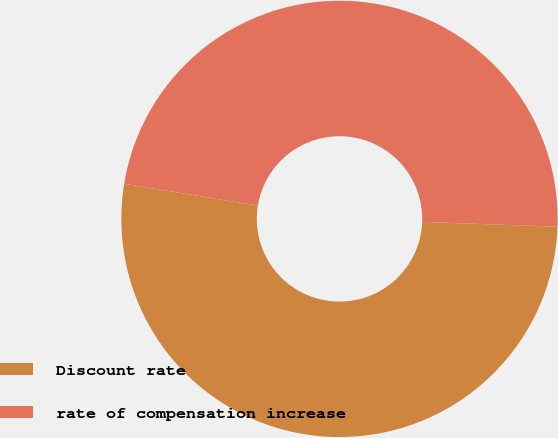Convert chart. <chart><loc_0><loc_0><loc_500><loc_500><pie_chart><fcel>Discount rate<fcel>rate of compensation increase<nl><fcel>52.0%<fcel>48.0%<nl></chart> 